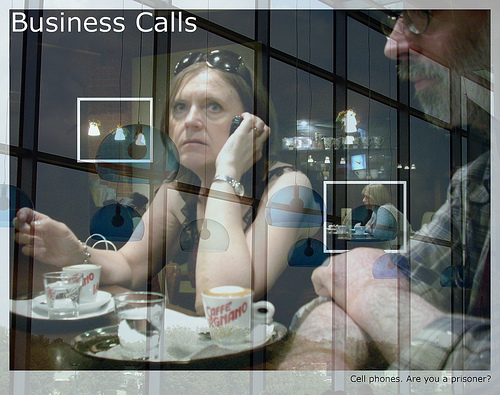Is the woman to the left or to the right of the man? The woman is positioned to the left of the man. 